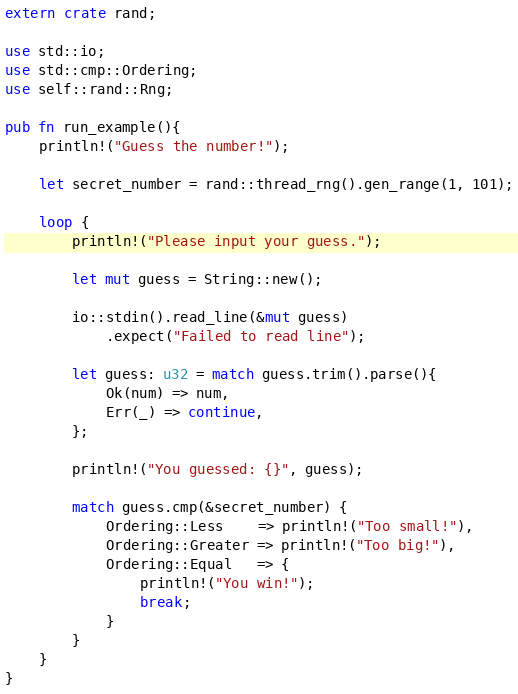Convert code to text. <code><loc_0><loc_0><loc_500><loc_500><_Rust_>extern crate rand;

use std::io;
use std::cmp::Ordering;
use self::rand::Rng;

pub fn run_example(){
    println!("Guess the number!");

    let secret_number = rand::thread_rng().gen_range(1, 101);

    loop {
        println!("Please input your guess.");

        let mut guess = String::new();

        io::stdin().read_line(&mut guess)
            .expect("Failed to read line");

        let guess: u32 = match guess.trim().parse(){
            Ok(num) => num,
            Err(_) => continue,
        };

        println!("You guessed: {}", guess);

        match guess.cmp(&secret_number) {
            Ordering::Less    => println!("Too small!"),
            Ordering::Greater => println!("Too big!"),
            Ordering::Equal   => {
                println!("You win!");
                break;
            }
        }
    }
}</code> 